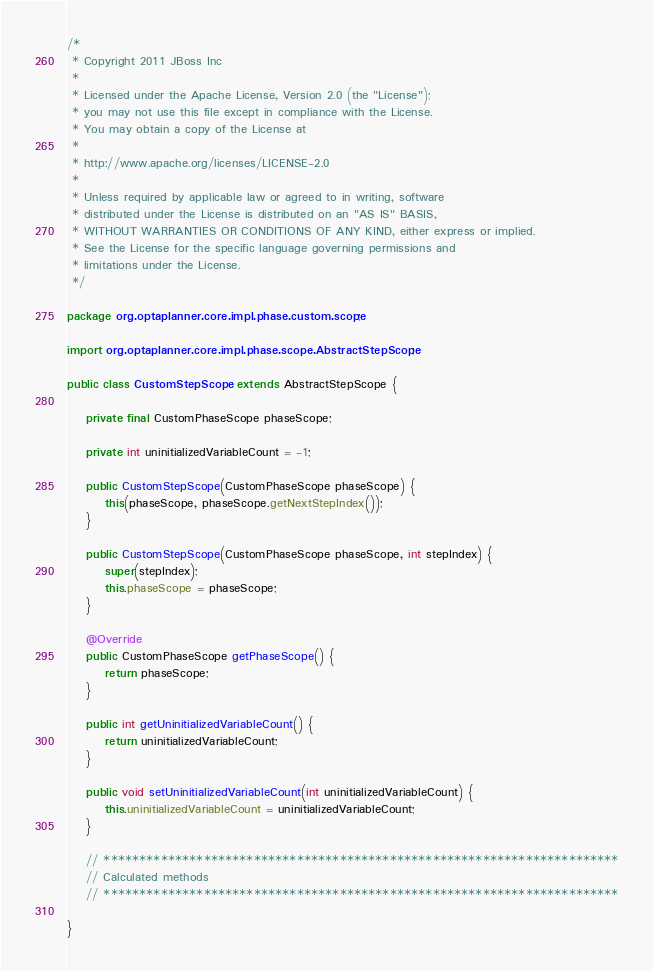Convert code to text. <code><loc_0><loc_0><loc_500><loc_500><_Java_>/*
 * Copyright 2011 JBoss Inc
 *
 * Licensed under the Apache License, Version 2.0 (the "License");
 * you may not use this file except in compliance with the License.
 * You may obtain a copy of the License at
 *
 * http://www.apache.org/licenses/LICENSE-2.0
 *
 * Unless required by applicable law or agreed to in writing, software
 * distributed under the License is distributed on an "AS IS" BASIS,
 * WITHOUT WARRANTIES OR CONDITIONS OF ANY KIND, either express or implied.
 * See the License for the specific language governing permissions and
 * limitations under the License.
 */

package org.optaplanner.core.impl.phase.custom.scope;

import org.optaplanner.core.impl.phase.scope.AbstractStepScope;

public class CustomStepScope extends AbstractStepScope {

    private final CustomPhaseScope phaseScope;

    private int uninitializedVariableCount = -1;

    public CustomStepScope(CustomPhaseScope phaseScope) {
        this(phaseScope, phaseScope.getNextStepIndex());
    }

    public CustomStepScope(CustomPhaseScope phaseScope, int stepIndex) {
        super(stepIndex);
        this.phaseScope = phaseScope;
    }

    @Override
    public CustomPhaseScope getPhaseScope() {
        return phaseScope;
    }

    public int getUninitializedVariableCount() {
        return uninitializedVariableCount;
    }

    public void setUninitializedVariableCount(int uninitializedVariableCount) {
        this.uninitializedVariableCount = uninitializedVariableCount;
    }

    // ************************************************************************
    // Calculated methods
    // ************************************************************************

}
</code> 